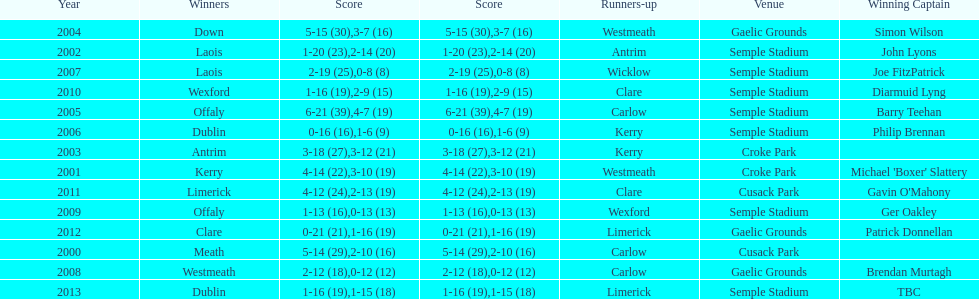Which team was the previous winner before dublin in 2013? Clare. 